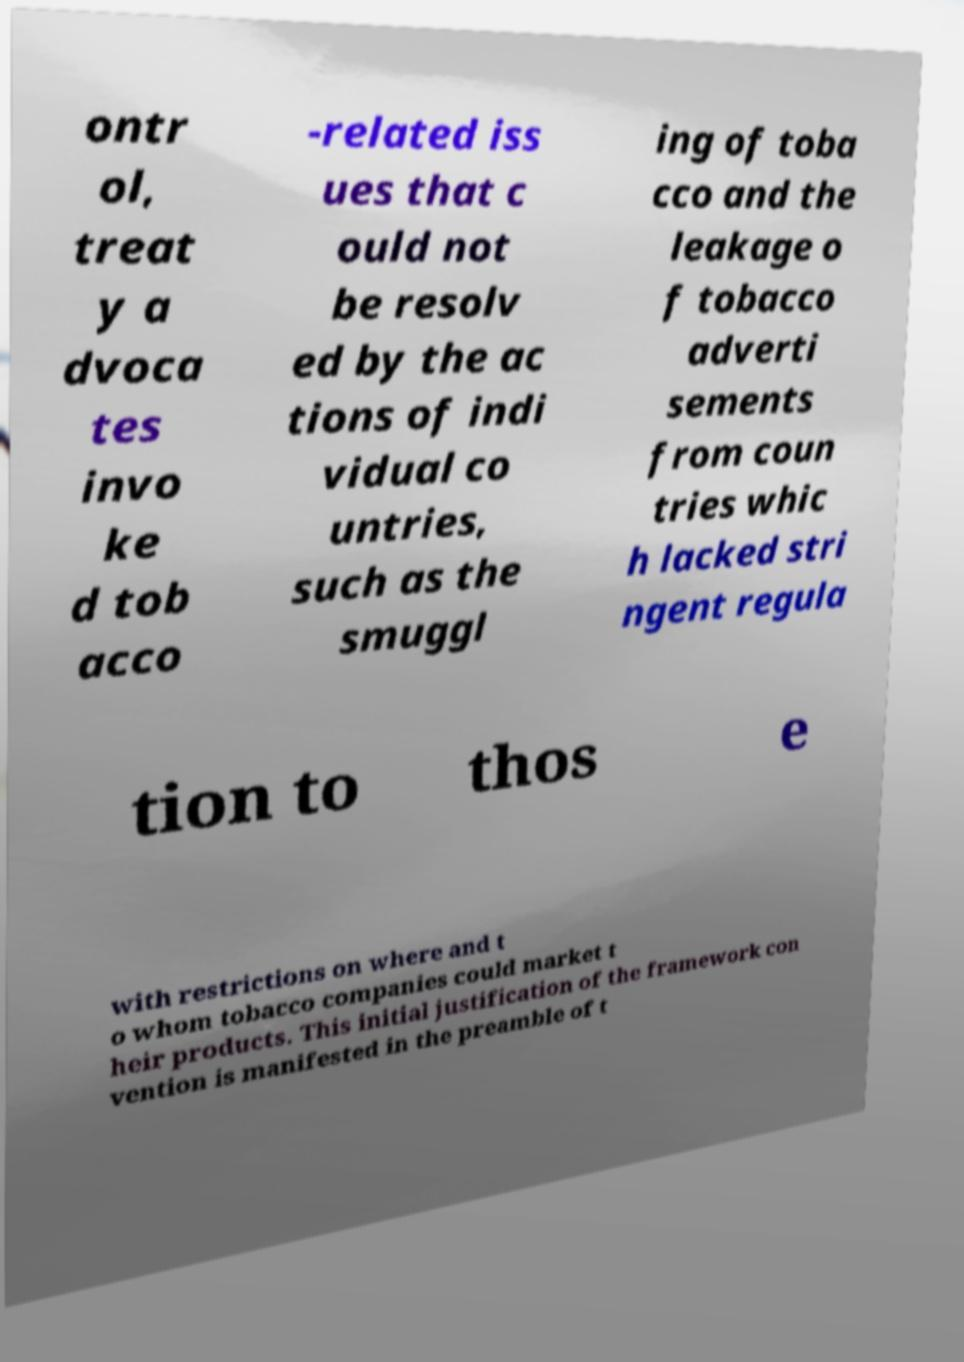Could you extract and type out the text from this image? ontr ol, treat y a dvoca tes invo ke d tob acco -related iss ues that c ould not be resolv ed by the ac tions of indi vidual co untries, such as the smuggl ing of toba cco and the leakage o f tobacco adverti sements from coun tries whic h lacked stri ngent regula tion to thos e with restrictions on where and t o whom tobacco companies could market t heir products. This initial justification of the framework con vention is manifested in the preamble of t 